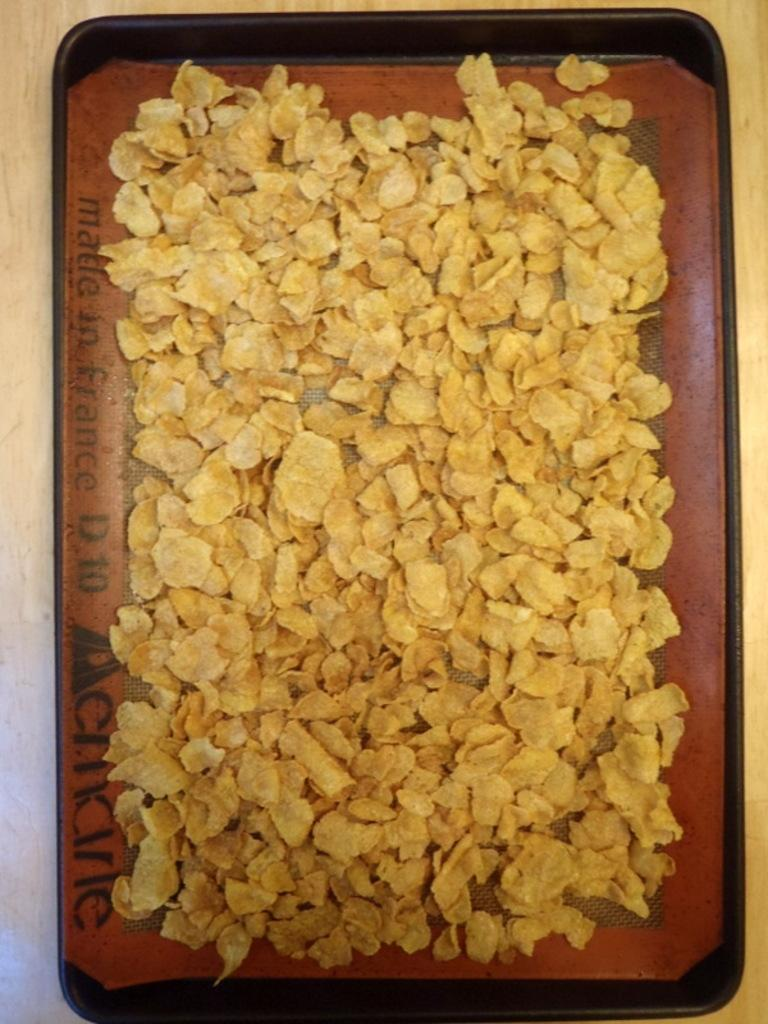What is the main subject of the image? There is a food item in the image. How is the food item arranged or presented? The food item is in a tray. Where is the tray placed? The tray is placed on a surface that resembles a table. What type of feather can be seen on the furniture in the image? There is no furniture or feather present in the image. 